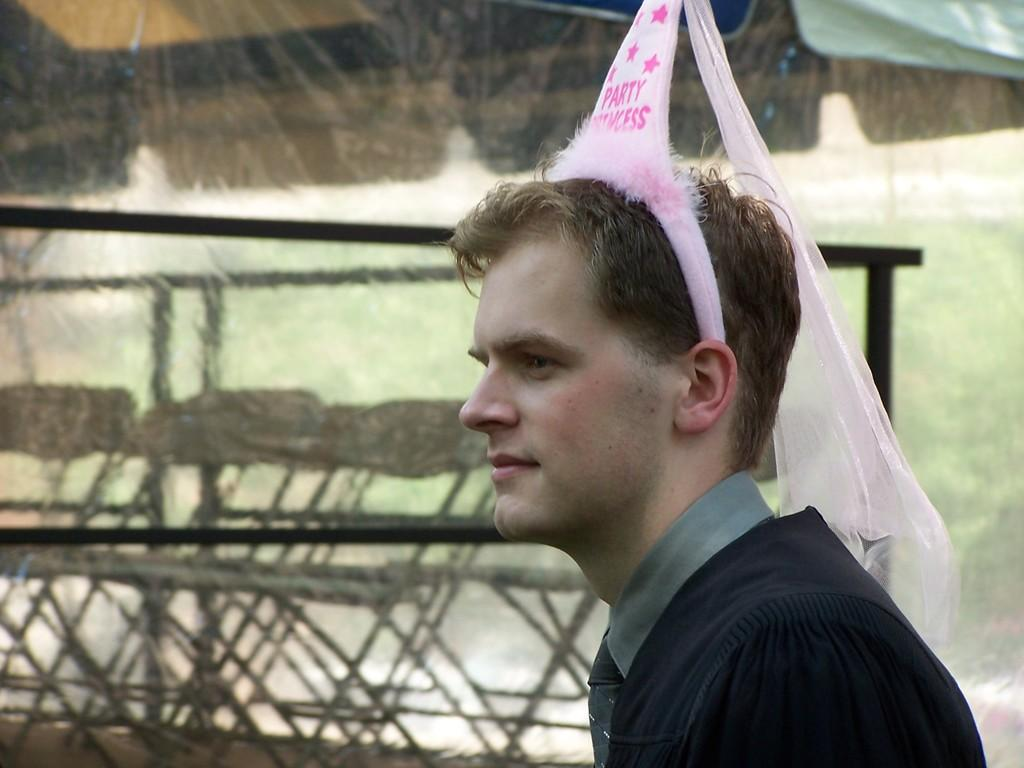Who is the main subject in the image? There is a person in the center of the image. What is the person wearing on their head? The person is wearing a hairband. What can be seen in the background of the image? There is a fence, water, and chairs visible in the background of the image. How many friends are flying with wings in the image? There are no friends or wings present in the image. 